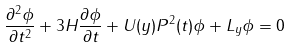Convert formula to latex. <formula><loc_0><loc_0><loc_500><loc_500>\frac { \partial ^ { 2 } \phi } { \partial t ^ { 2 } } + 3 H \frac { \partial \phi } { \partial t } + U ( y ) P ^ { 2 } ( t ) \phi + L _ { y } \phi = 0</formula> 